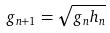Convert formula to latex. <formula><loc_0><loc_0><loc_500><loc_500>g _ { n + 1 } = \sqrt { g _ { n } h _ { n } }</formula> 